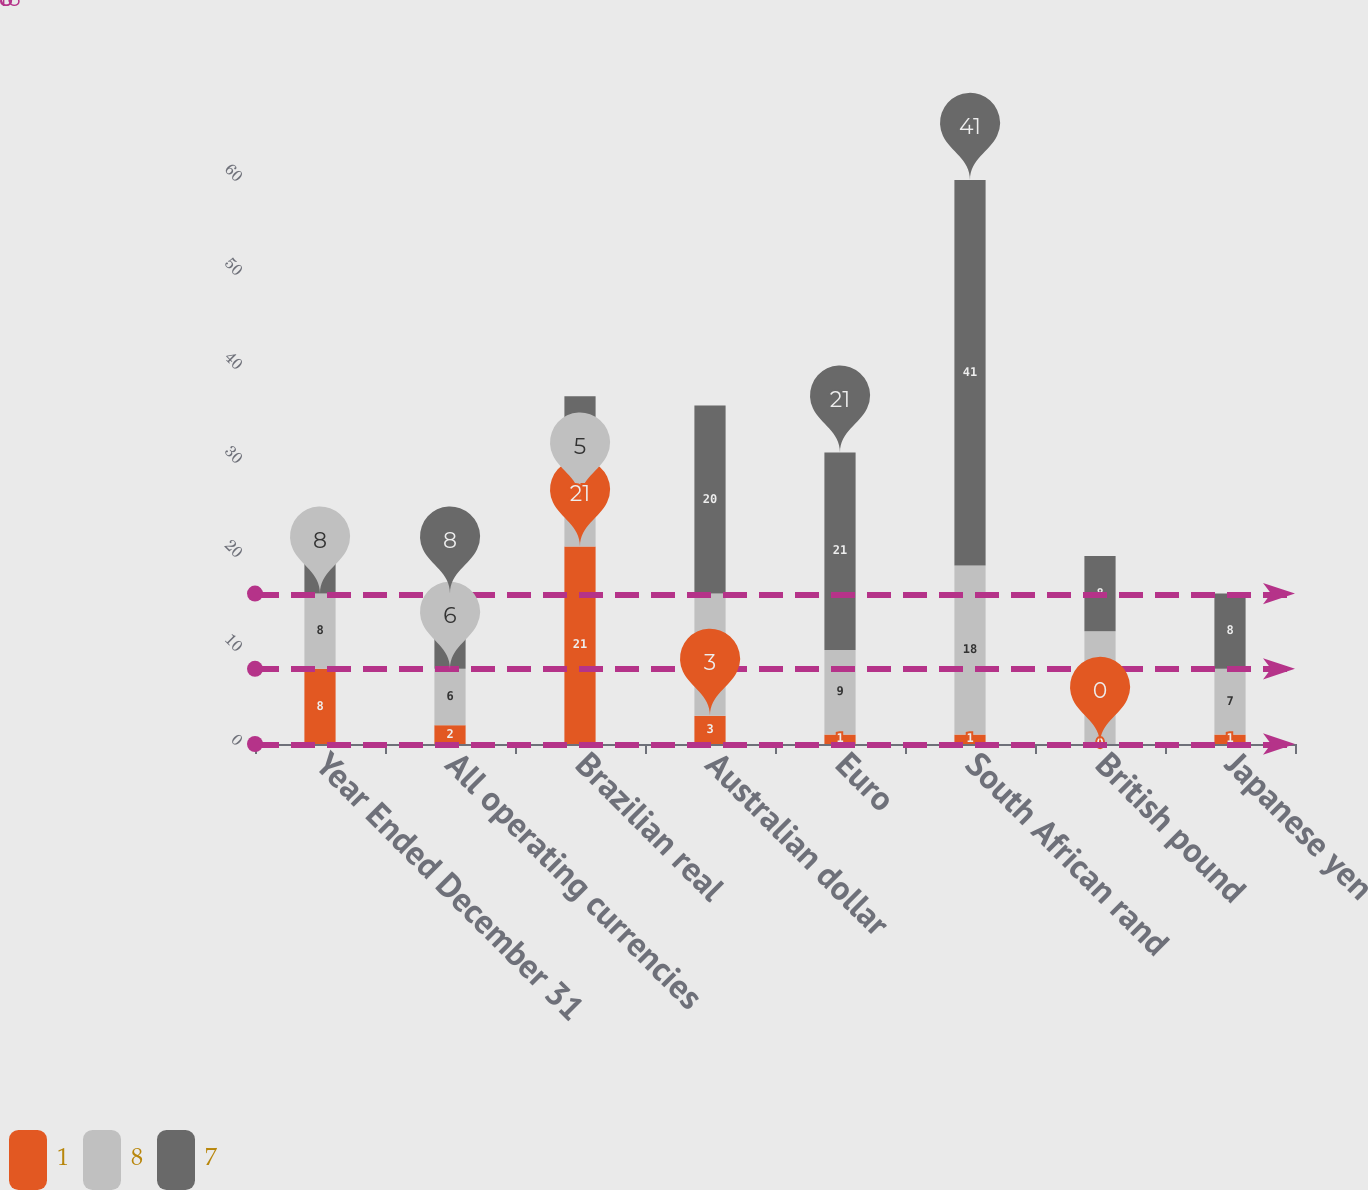Convert chart to OTSL. <chart><loc_0><loc_0><loc_500><loc_500><stacked_bar_chart><ecel><fcel>Year Ended December 31<fcel>All operating currencies<fcel>Brazilian real<fcel>Australian dollar<fcel>Euro<fcel>South African rand<fcel>British pound<fcel>Japanese yen<nl><fcel>1<fcel>8<fcel>2<fcel>21<fcel>3<fcel>1<fcel>1<fcel>0<fcel>1<nl><fcel>8<fcel>8<fcel>6<fcel>5<fcel>13<fcel>9<fcel>18<fcel>12<fcel>7<nl><fcel>7<fcel>8<fcel>8<fcel>11<fcel>20<fcel>21<fcel>41<fcel>8<fcel>8<nl></chart> 